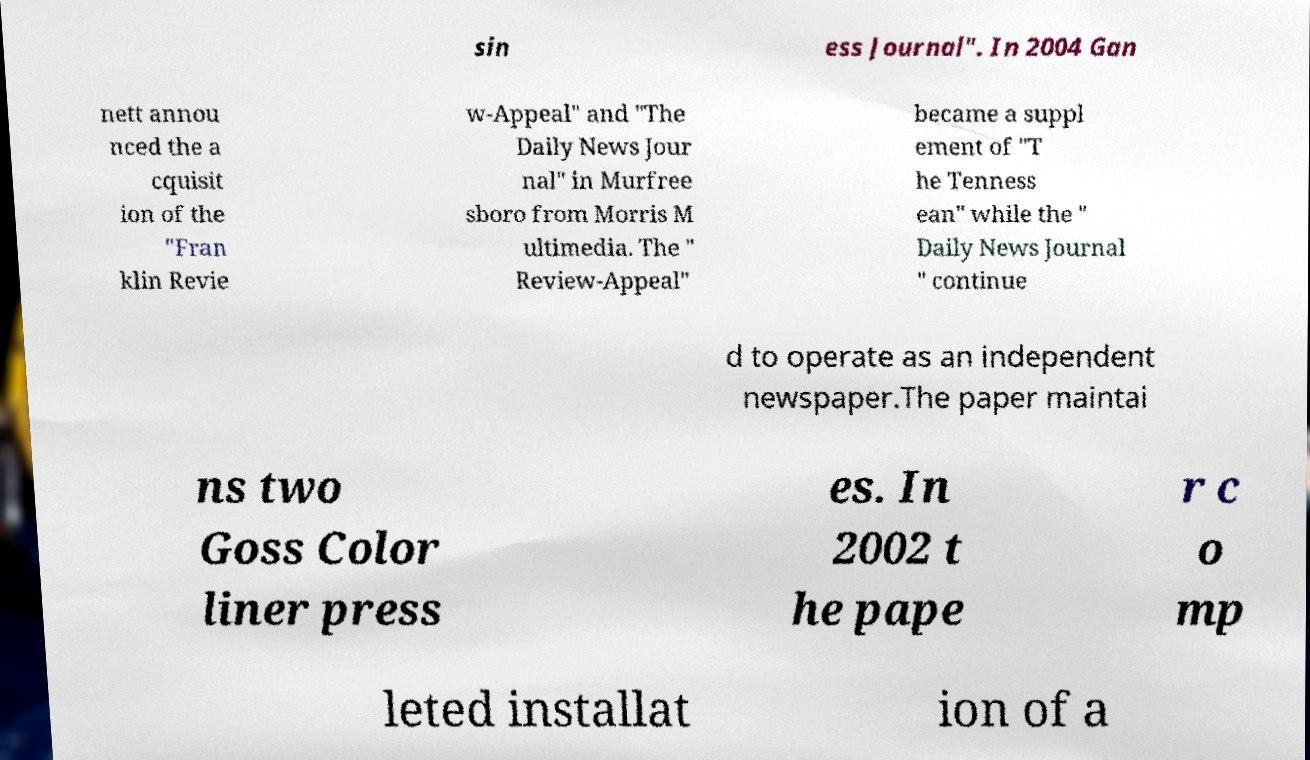Could you extract and type out the text from this image? sin ess Journal". In 2004 Gan nett annou nced the a cquisit ion of the "Fran klin Revie w-Appeal" and "The Daily News Jour nal" in Murfree sboro from Morris M ultimedia. The " Review-Appeal" became a suppl ement of "T he Tenness ean" while the " Daily News Journal " continue d to operate as an independent newspaper.The paper maintai ns two Goss Color liner press es. In 2002 t he pape r c o mp leted installat ion of a 